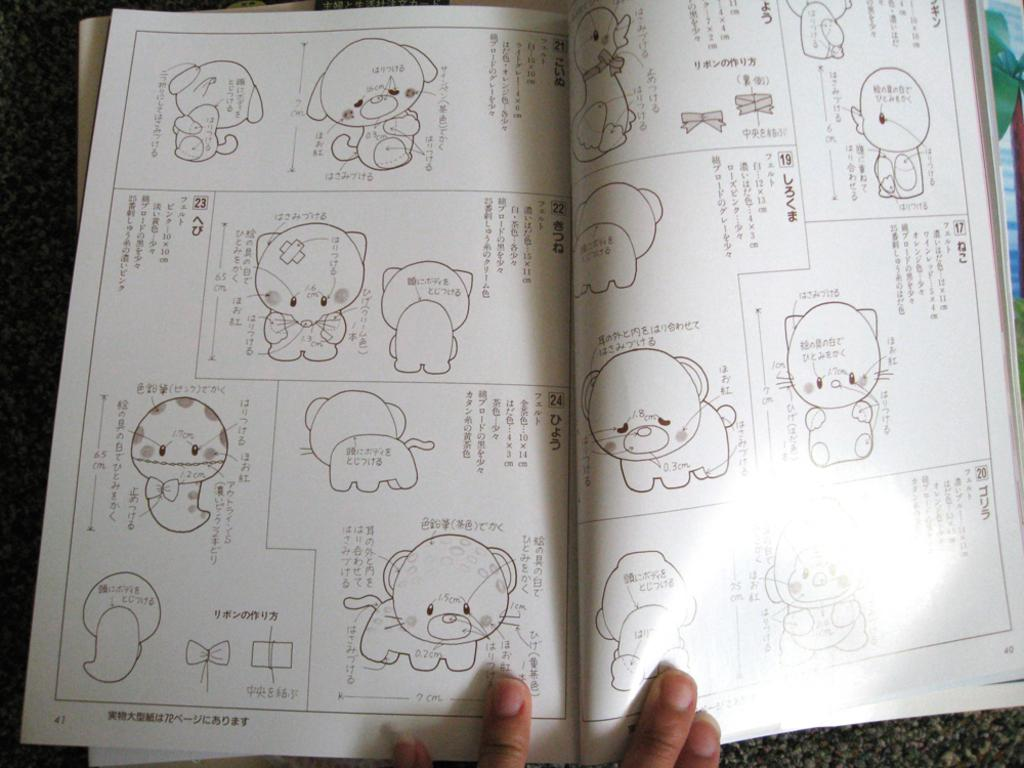What is the main subject of the image? The main subject of the image is a book on top of another book on a platform. Are there any other books visible in the image? Yes, there is a book in the top right corner of the image. Can you describe any other elements in the image? Fingers are visible at the bottom of the image. What type of hobbies does the toad in the image enjoy? There is no toad present in the image, so it is not possible to determine what hobbies it might enjoy. 